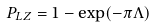<formula> <loc_0><loc_0><loc_500><loc_500>P _ { L Z } = 1 - \exp ( - \pi \Lambda )</formula> 